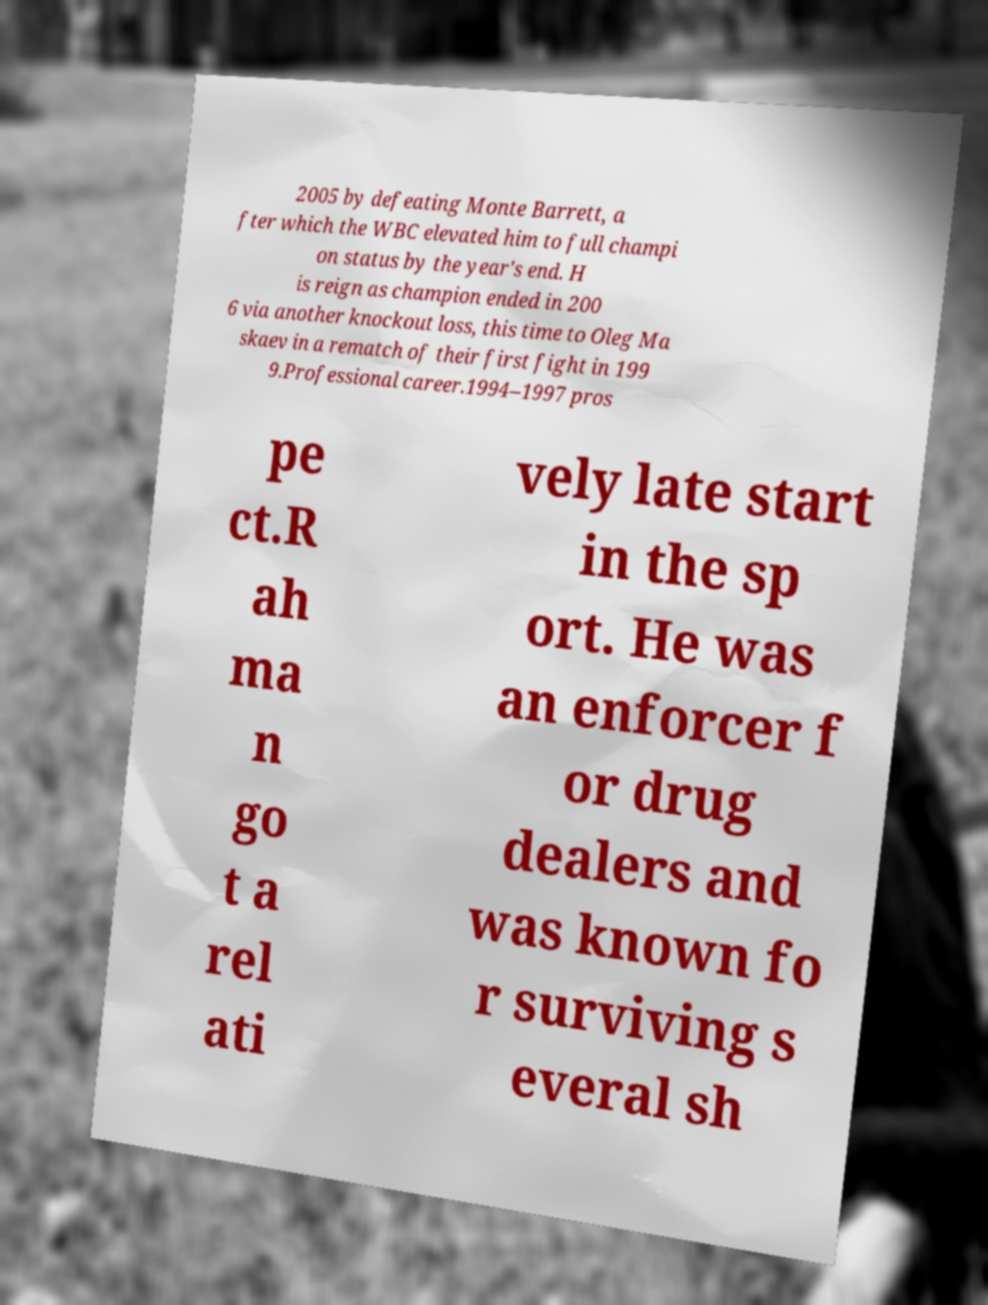Could you assist in decoding the text presented in this image and type it out clearly? 2005 by defeating Monte Barrett, a fter which the WBC elevated him to full champi on status by the year's end. H is reign as champion ended in 200 6 via another knockout loss, this time to Oleg Ma skaev in a rematch of their first fight in 199 9.Professional career.1994–1997 pros pe ct.R ah ma n go t a rel ati vely late start in the sp ort. He was an enforcer f or drug dealers and was known fo r surviving s everal sh 